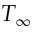Convert formula to latex. <formula><loc_0><loc_0><loc_500><loc_500>T _ { \infty }</formula> 